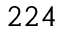Convert formula to latex. <formula><loc_0><loc_0><loc_500><loc_500>2 2 4</formula> 